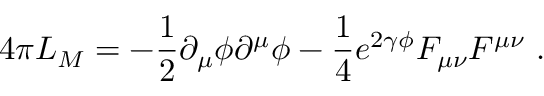<formula> <loc_0><loc_0><loc_500><loc_500>4 \pi L _ { M } = - \frac { 1 } { 2 } \partial _ { \mu } \phi \partial ^ { \mu } \phi - \frac { 1 } { 4 } e ^ { 2 \gamma \phi } F _ { \mu \nu } F ^ { \mu \nu } \ .</formula> 